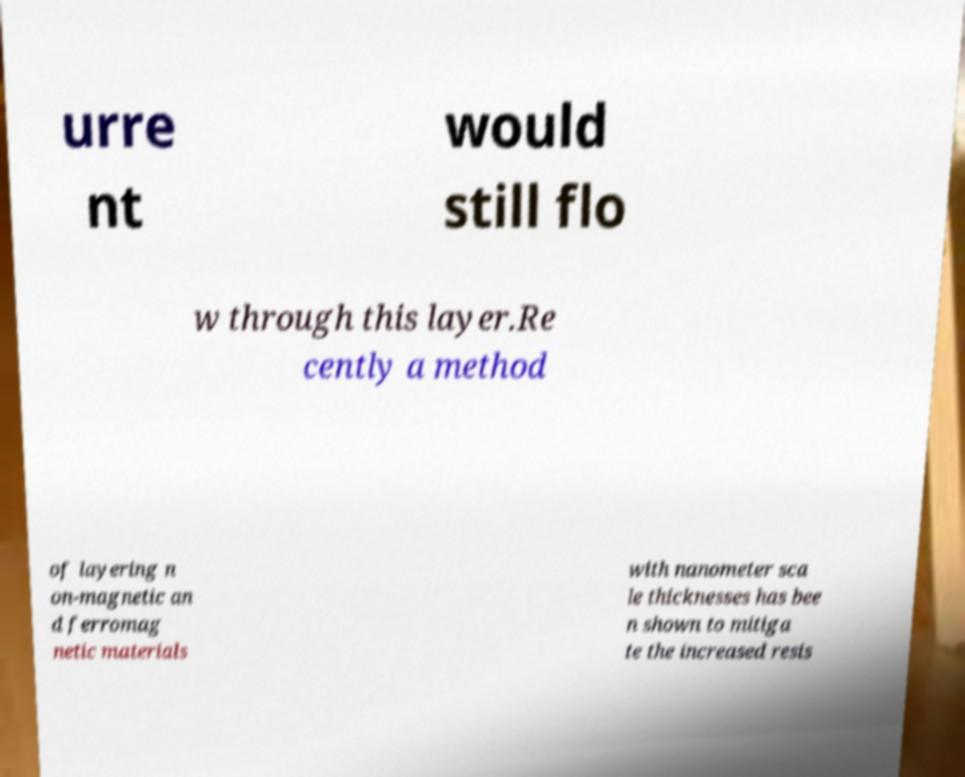For documentation purposes, I need the text within this image transcribed. Could you provide that? urre nt would still flo w through this layer.Re cently a method of layering n on-magnetic an d ferromag netic materials with nanometer sca le thicknesses has bee n shown to mitiga te the increased resis 